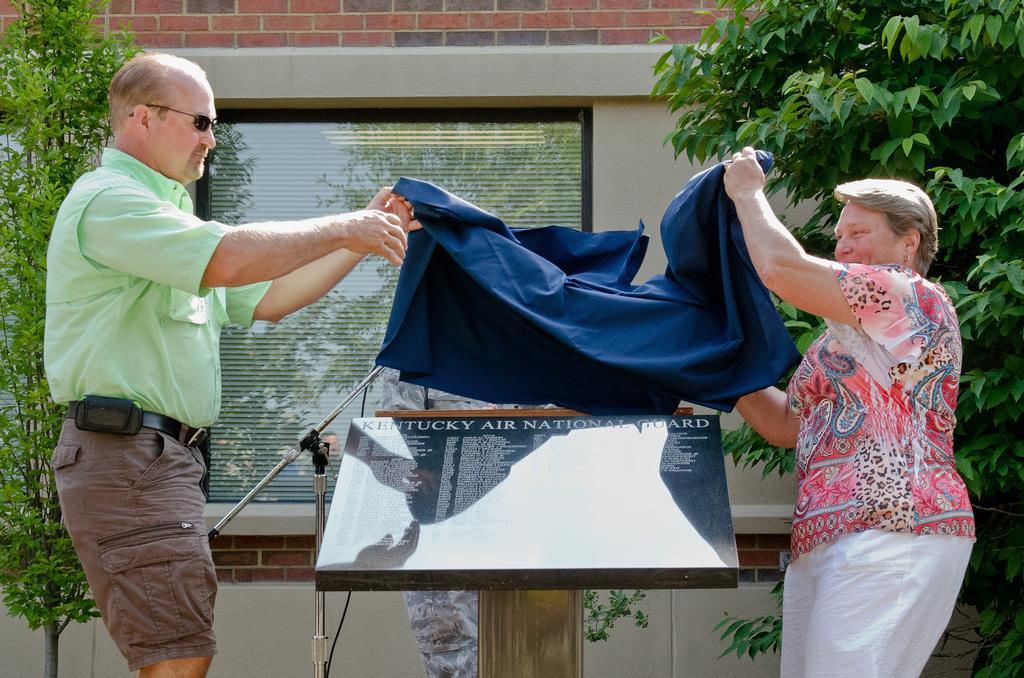Can you describe this image briefly? Here we can see a man and a woman holding a cloth with their hands. There are trees, board, and a glass. In the background we can see a wall. 